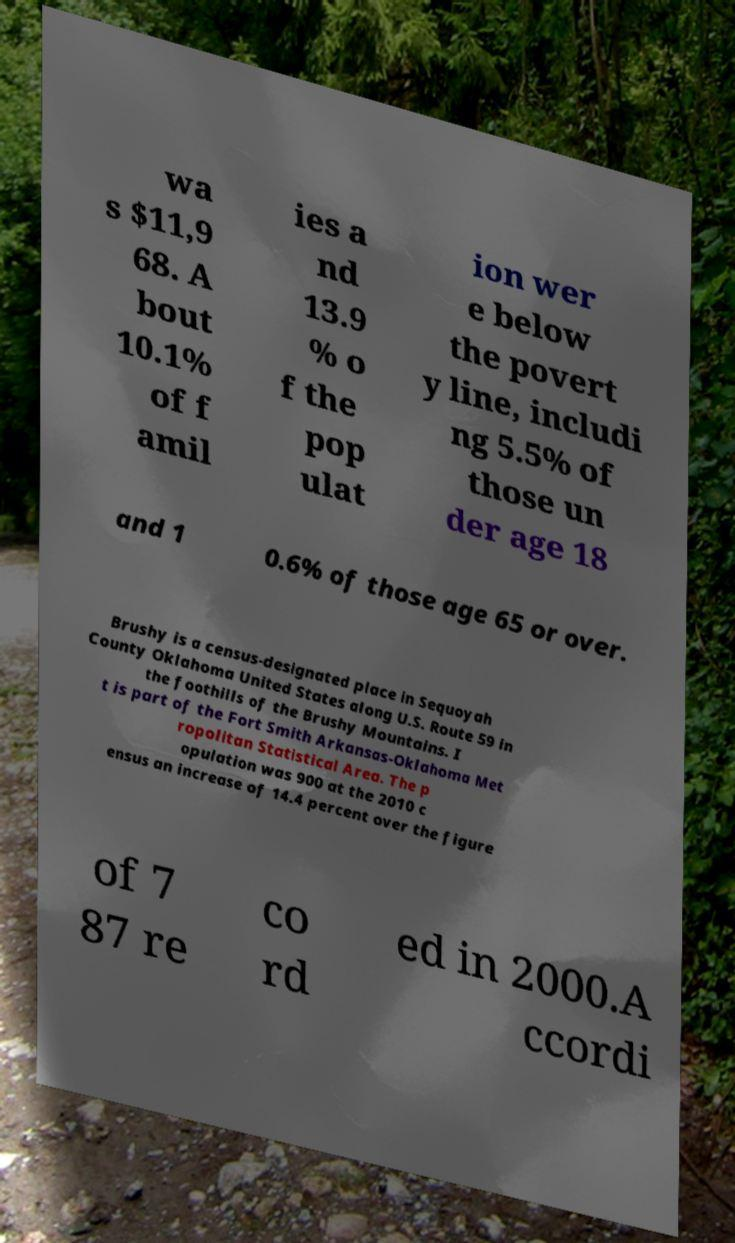Please read and relay the text visible in this image. What does it say? wa s $11,9 68. A bout 10.1% of f amil ies a nd 13.9 % o f the pop ulat ion wer e below the povert y line, includi ng 5.5% of those un der age 18 and 1 0.6% of those age 65 or over. Brushy is a census-designated place in Sequoyah County Oklahoma United States along U.S. Route 59 in the foothills of the Brushy Mountains. I t is part of the Fort Smith Arkansas-Oklahoma Met ropolitan Statistical Area. The p opulation was 900 at the 2010 c ensus an increase of 14.4 percent over the figure of 7 87 re co rd ed in 2000.A ccordi 